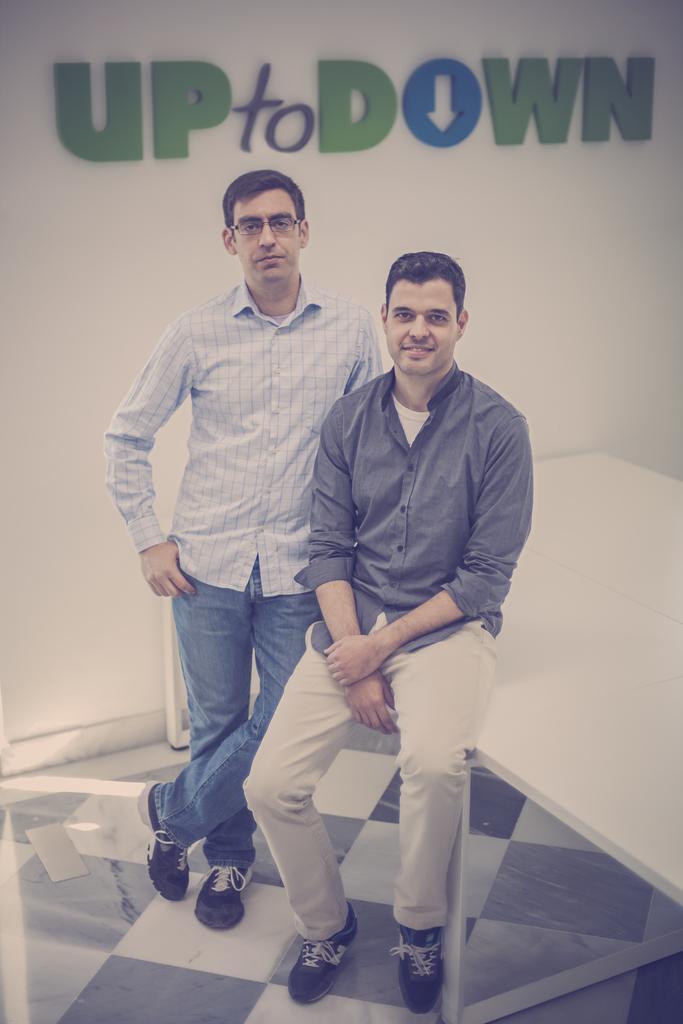In one or two sentences, can you explain what this image depicts? This is an inside view. In the middle of the image there are two men giving pose for the picture. The man who is on the right side is sitting on a table and smiling. Another man is standing beside him. At the bottom, I can see the floor. In the background there is a wall on which few letter blocks are attached. 